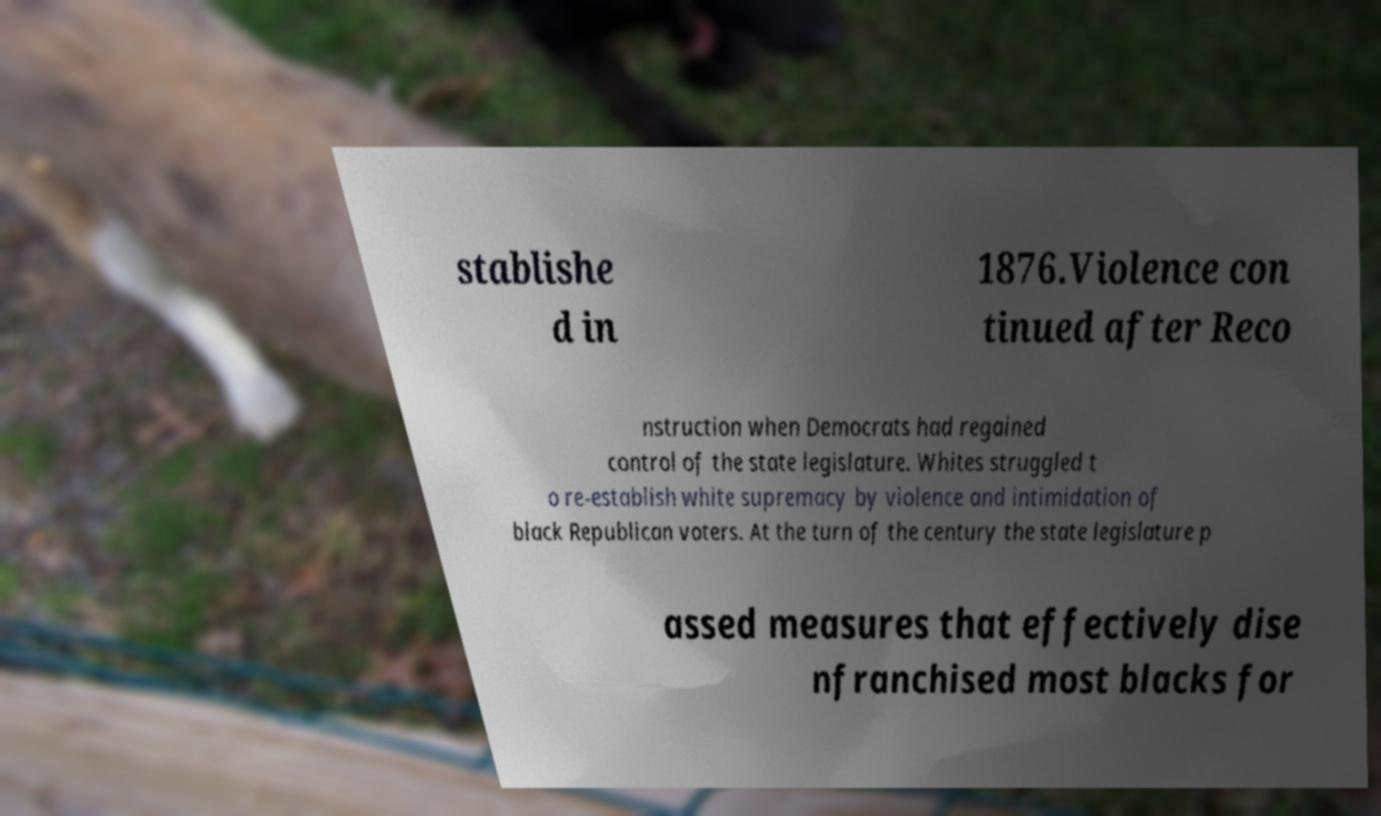Can you read and provide the text displayed in the image?This photo seems to have some interesting text. Can you extract and type it out for me? stablishe d in 1876.Violence con tinued after Reco nstruction when Democrats had regained control of the state legislature. Whites struggled t o re-establish white supremacy by violence and intimidation of black Republican voters. At the turn of the century the state legislature p assed measures that effectively dise nfranchised most blacks for 